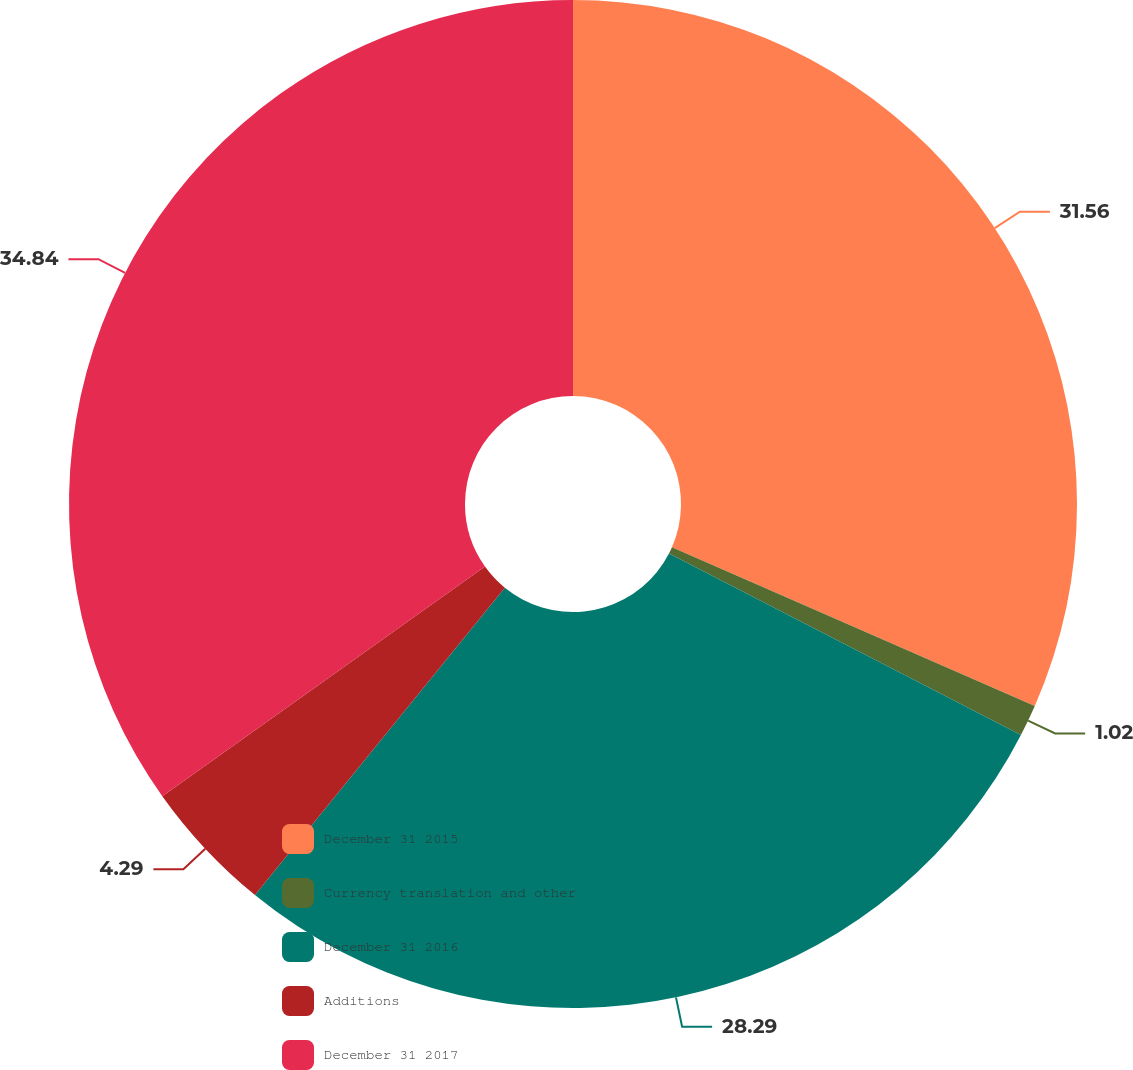Convert chart. <chart><loc_0><loc_0><loc_500><loc_500><pie_chart><fcel>December 31 2015<fcel>Currency translation and other<fcel>December 31 2016<fcel>Additions<fcel>December 31 2017<nl><fcel>31.56%<fcel>1.02%<fcel>28.29%<fcel>4.29%<fcel>34.84%<nl></chart> 